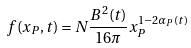<formula> <loc_0><loc_0><loc_500><loc_500>f ( x _ { P } , t ) = N { \frac { B ^ { 2 } ( t ) } { 1 6 \pi } } x _ { P } ^ { 1 - 2 \alpha _ { P } ( t ) }</formula> 